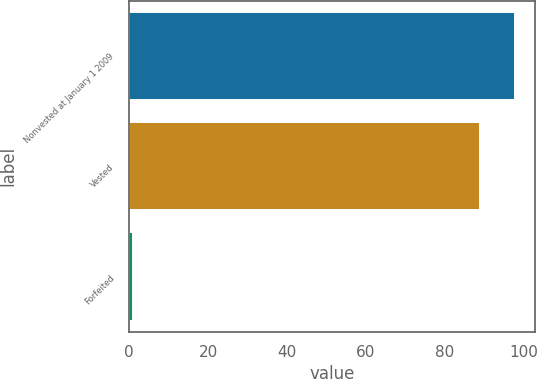<chart> <loc_0><loc_0><loc_500><loc_500><bar_chart><fcel>Nonvested at January 1 2009<fcel>Vested<fcel>Forfeited<nl><fcel>97.9<fcel>89<fcel>1<nl></chart> 